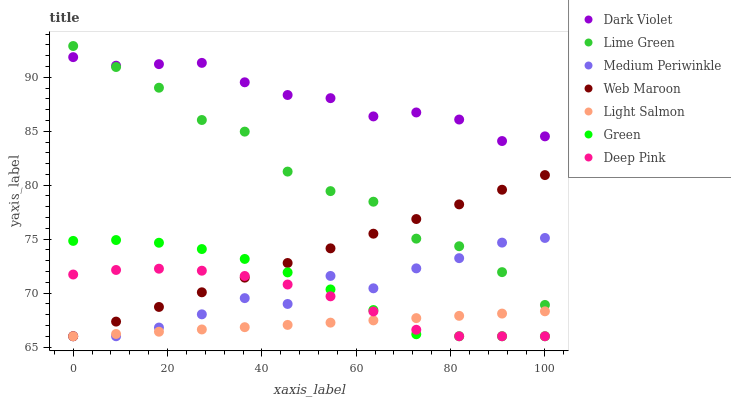Does Light Salmon have the minimum area under the curve?
Answer yes or no. Yes. Does Dark Violet have the maximum area under the curve?
Answer yes or no. Yes. Does Deep Pink have the minimum area under the curve?
Answer yes or no. No. Does Deep Pink have the maximum area under the curve?
Answer yes or no. No. Is Web Maroon the smoothest?
Answer yes or no. Yes. Is Lime Green the roughest?
Answer yes or no. Yes. Is Deep Pink the smoothest?
Answer yes or no. No. Is Deep Pink the roughest?
Answer yes or no. No. Does Light Salmon have the lowest value?
Answer yes or no. Yes. Does Dark Violet have the lowest value?
Answer yes or no. No. Does Lime Green have the highest value?
Answer yes or no. Yes. Does Deep Pink have the highest value?
Answer yes or no. No. Is Light Salmon less than Lime Green?
Answer yes or no. Yes. Is Dark Violet greater than Web Maroon?
Answer yes or no. Yes. Does Medium Periwinkle intersect Green?
Answer yes or no. Yes. Is Medium Periwinkle less than Green?
Answer yes or no. No. Is Medium Periwinkle greater than Green?
Answer yes or no. No. Does Light Salmon intersect Lime Green?
Answer yes or no. No. 